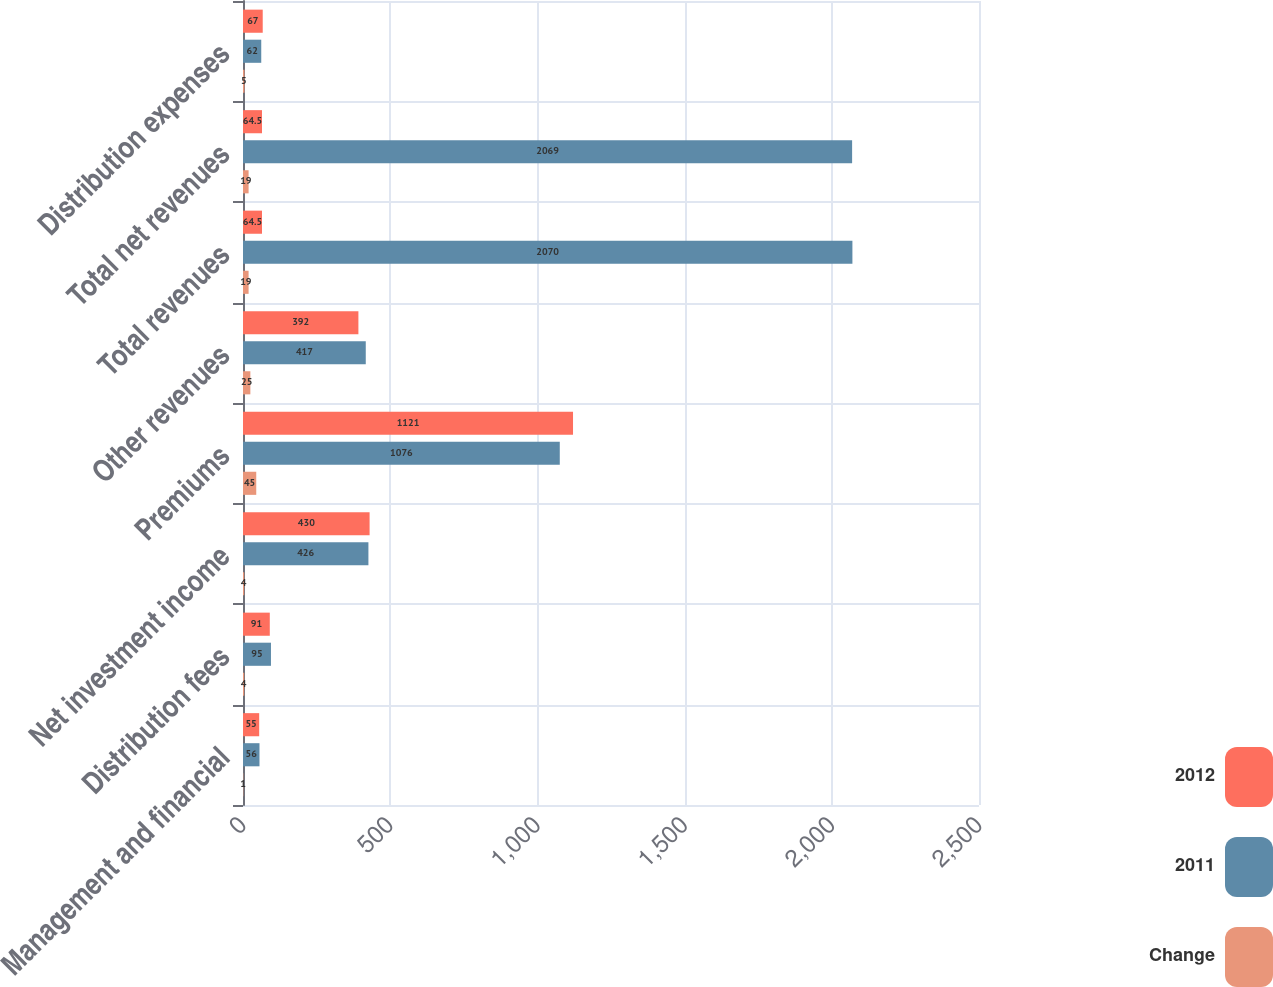Convert chart to OTSL. <chart><loc_0><loc_0><loc_500><loc_500><stacked_bar_chart><ecel><fcel>Management and financial<fcel>Distribution fees<fcel>Net investment income<fcel>Premiums<fcel>Other revenues<fcel>Total revenues<fcel>Total net revenues<fcel>Distribution expenses<nl><fcel>2012<fcel>55<fcel>91<fcel>430<fcel>1121<fcel>392<fcel>64.5<fcel>64.5<fcel>67<nl><fcel>2011<fcel>56<fcel>95<fcel>426<fcel>1076<fcel>417<fcel>2070<fcel>2069<fcel>62<nl><fcel>Change<fcel>1<fcel>4<fcel>4<fcel>45<fcel>25<fcel>19<fcel>19<fcel>5<nl></chart> 